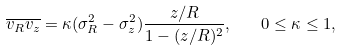<formula> <loc_0><loc_0><loc_500><loc_500>\overline { v _ { R } v _ { z } } = \kappa ( \sigma _ { R } ^ { 2 } - \sigma _ { z } ^ { 2 } ) \frac { z / R } { 1 - ( z / R ) ^ { 2 } } , \quad 0 \leq \kappa \leq 1 ,</formula> 